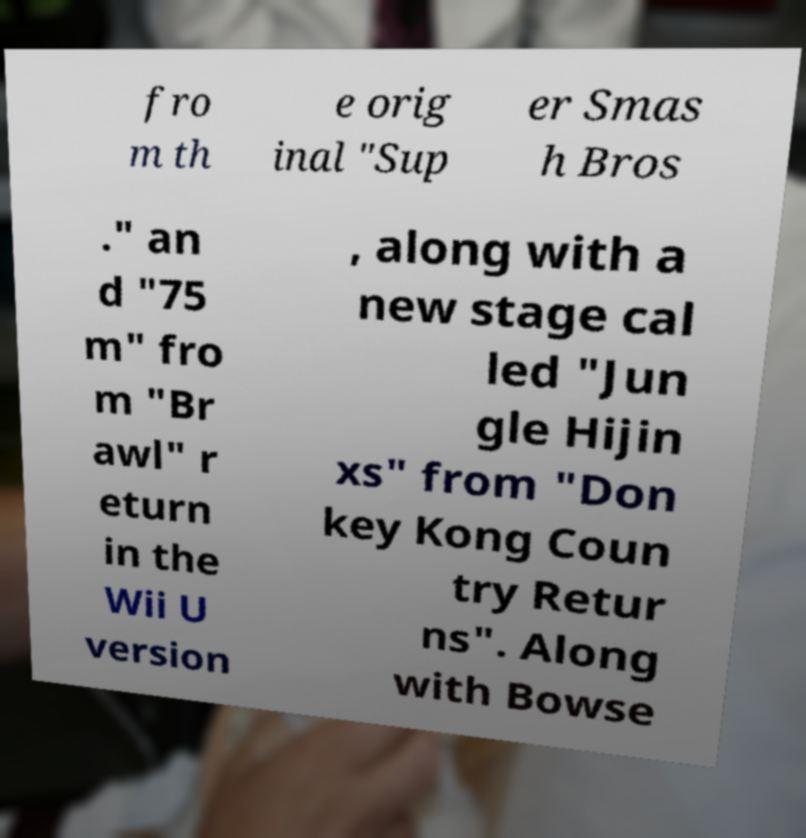Please read and relay the text visible in this image. What does it say? fro m th e orig inal "Sup er Smas h Bros ." an d "75 m" fro m "Br awl" r eturn in the Wii U version , along with a new stage cal led "Jun gle Hijin xs" from "Don key Kong Coun try Retur ns". Along with Bowse 